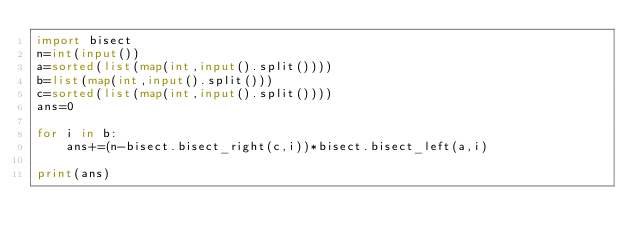Convert code to text. <code><loc_0><loc_0><loc_500><loc_500><_Python_>import bisect
n=int(input())
a=sorted(list(map(int,input().split())))
b=list(map(int,input().split()))
c=sorted(list(map(int,input().split())))
ans=0

for i in b:
    ans+=(n-bisect.bisect_right(c,i))*bisect.bisect_left(a,i)

print(ans)</code> 